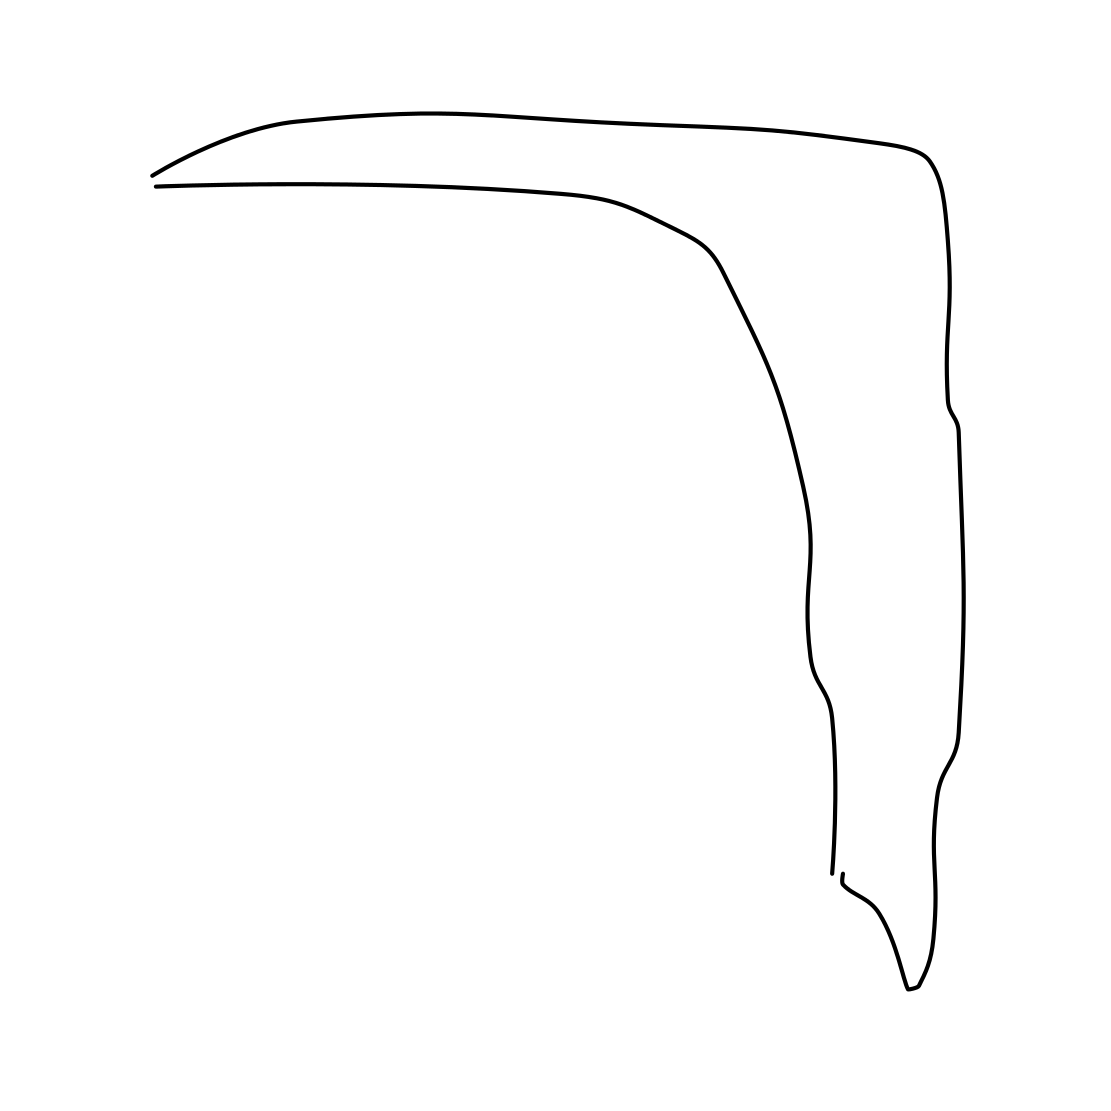Could this image symbolize anything specific? This image could symbolize minimalism or the concept of 'less is more.' It uses the bare essentials to convey an image, encouraging viewers to focus on the basic form and inherent beauty without distraction. 